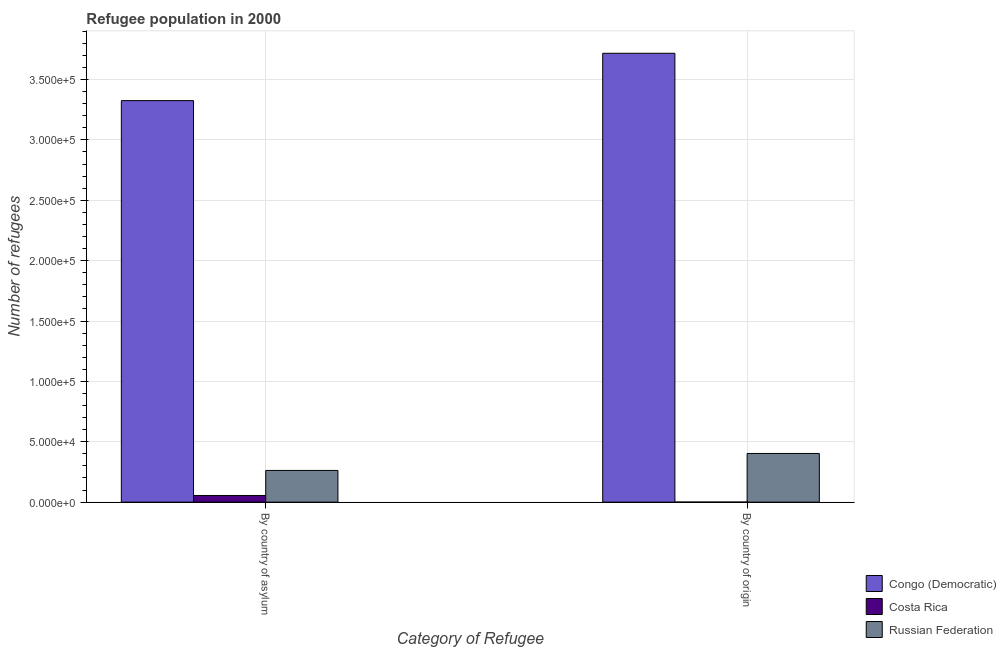How many groups of bars are there?
Offer a very short reply. 2. Are the number of bars per tick equal to the number of legend labels?
Provide a succinct answer. Yes. What is the label of the 2nd group of bars from the left?
Offer a very short reply. By country of origin. What is the number of refugees by country of asylum in Costa Rica?
Offer a terse response. 5519. Across all countries, what is the maximum number of refugees by country of origin?
Your answer should be compact. 3.72e+05. Across all countries, what is the minimum number of refugees by country of asylum?
Provide a succinct answer. 5519. In which country was the number of refugees by country of origin maximum?
Offer a very short reply. Congo (Democratic). In which country was the number of refugees by country of asylum minimum?
Offer a very short reply. Costa Rica. What is the total number of refugees by country of asylum in the graph?
Your answer should be compact. 3.64e+05. What is the difference between the number of refugees by country of asylum in Congo (Democratic) and that in Russian Federation?
Offer a very short reply. 3.06e+05. What is the difference between the number of refugees by country of origin in Costa Rica and the number of refugees by country of asylum in Congo (Democratic)?
Your response must be concise. -3.32e+05. What is the average number of refugees by country of asylum per country?
Provide a short and direct response. 1.21e+05. What is the difference between the number of refugees by country of asylum and number of refugees by country of origin in Costa Rica?
Your answer should be compact. 5462. In how many countries, is the number of refugees by country of asylum greater than 20000 ?
Give a very brief answer. 2. What is the ratio of the number of refugees by country of asylum in Congo (Democratic) to that in Russian Federation?
Your answer should be very brief. 12.66. Is the number of refugees by country of origin in Congo (Democratic) less than that in Russian Federation?
Provide a succinct answer. No. What does the 3rd bar from the left in By country of origin represents?
Your answer should be compact. Russian Federation. What does the 3rd bar from the right in By country of origin represents?
Your response must be concise. Congo (Democratic). How many bars are there?
Provide a short and direct response. 6. Are all the bars in the graph horizontal?
Ensure brevity in your answer.  No. How many countries are there in the graph?
Offer a very short reply. 3. Does the graph contain grids?
Your answer should be very brief. Yes. How many legend labels are there?
Your answer should be very brief. 3. How are the legend labels stacked?
Make the answer very short. Vertical. What is the title of the graph?
Offer a terse response. Refugee population in 2000. What is the label or title of the X-axis?
Offer a very short reply. Category of Refugee. What is the label or title of the Y-axis?
Provide a short and direct response. Number of refugees. What is the Number of refugees of Congo (Democratic) in By country of asylum?
Ensure brevity in your answer.  3.33e+05. What is the Number of refugees in Costa Rica in By country of asylum?
Your answer should be compact. 5519. What is the Number of refugees in Russian Federation in By country of asylum?
Give a very brief answer. 2.63e+04. What is the Number of refugees of Congo (Democratic) in By country of origin?
Make the answer very short. 3.72e+05. What is the Number of refugees in Costa Rica in By country of origin?
Your response must be concise. 57. What is the Number of refugees of Russian Federation in By country of origin?
Your answer should be very brief. 4.03e+04. Across all Category of Refugee, what is the maximum Number of refugees in Congo (Democratic)?
Ensure brevity in your answer.  3.72e+05. Across all Category of Refugee, what is the maximum Number of refugees in Costa Rica?
Provide a succinct answer. 5519. Across all Category of Refugee, what is the maximum Number of refugees of Russian Federation?
Your answer should be compact. 4.03e+04. Across all Category of Refugee, what is the minimum Number of refugees in Congo (Democratic)?
Your answer should be compact. 3.33e+05. Across all Category of Refugee, what is the minimum Number of refugees in Russian Federation?
Make the answer very short. 2.63e+04. What is the total Number of refugees of Congo (Democratic) in the graph?
Offer a terse response. 7.04e+05. What is the total Number of refugees of Costa Rica in the graph?
Make the answer very short. 5576. What is the total Number of refugees in Russian Federation in the graph?
Your response must be concise. 6.66e+04. What is the difference between the Number of refugees of Congo (Democratic) in By country of asylum and that in By country of origin?
Give a very brief answer. -3.92e+04. What is the difference between the Number of refugees of Costa Rica in By country of asylum and that in By country of origin?
Offer a very short reply. 5462. What is the difference between the Number of refugees of Russian Federation in By country of asylum and that in By country of origin?
Ensure brevity in your answer.  -1.40e+04. What is the difference between the Number of refugees in Congo (Democratic) in By country of asylum and the Number of refugees in Costa Rica in By country of origin?
Your answer should be very brief. 3.32e+05. What is the difference between the Number of refugees of Congo (Democratic) in By country of asylum and the Number of refugees of Russian Federation in By country of origin?
Keep it short and to the point. 2.92e+05. What is the difference between the Number of refugees of Costa Rica in By country of asylum and the Number of refugees of Russian Federation in By country of origin?
Offer a very short reply. -3.48e+04. What is the average Number of refugees in Congo (Democratic) per Category of Refugee?
Provide a succinct answer. 3.52e+05. What is the average Number of refugees in Costa Rica per Category of Refugee?
Offer a terse response. 2788. What is the average Number of refugees of Russian Federation per Category of Refugee?
Make the answer very short. 3.33e+04. What is the difference between the Number of refugees in Congo (Democratic) and Number of refugees in Costa Rica in By country of asylum?
Offer a terse response. 3.27e+05. What is the difference between the Number of refugees of Congo (Democratic) and Number of refugees of Russian Federation in By country of asylum?
Make the answer very short. 3.06e+05. What is the difference between the Number of refugees in Costa Rica and Number of refugees in Russian Federation in By country of asylum?
Give a very brief answer. -2.07e+04. What is the difference between the Number of refugees of Congo (Democratic) and Number of refugees of Costa Rica in By country of origin?
Your response must be concise. 3.72e+05. What is the difference between the Number of refugees in Congo (Democratic) and Number of refugees in Russian Federation in By country of origin?
Offer a terse response. 3.31e+05. What is the difference between the Number of refugees in Costa Rica and Number of refugees in Russian Federation in By country of origin?
Your response must be concise. -4.03e+04. What is the ratio of the Number of refugees of Congo (Democratic) in By country of asylum to that in By country of origin?
Ensure brevity in your answer.  0.89. What is the ratio of the Number of refugees in Costa Rica in By country of asylum to that in By country of origin?
Make the answer very short. 96.82. What is the ratio of the Number of refugees of Russian Federation in By country of asylum to that in By country of origin?
Your response must be concise. 0.65. What is the difference between the highest and the second highest Number of refugees in Congo (Democratic)?
Keep it short and to the point. 3.92e+04. What is the difference between the highest and the second highest Number of refugees in Costa Rica?
Your answer should be very brief. 5462. What is the difference between the highest and the second highest Number of refugees in Russian Federation?
Offer a very short reply. 1.40e+04. What is the difference between the highest and the lowest Number of refugees of Congo (Democratic)?
Provide a short and direct response. 3.92e+04. What is the difference between the highest and the lowest Number of refugees in Costa Rica?
Your answer should be very brief. 5462. What is the difference between the highest and the lowest Number of refugees of Russian Federation?
Your answer should be compact. 1.40e+04. 